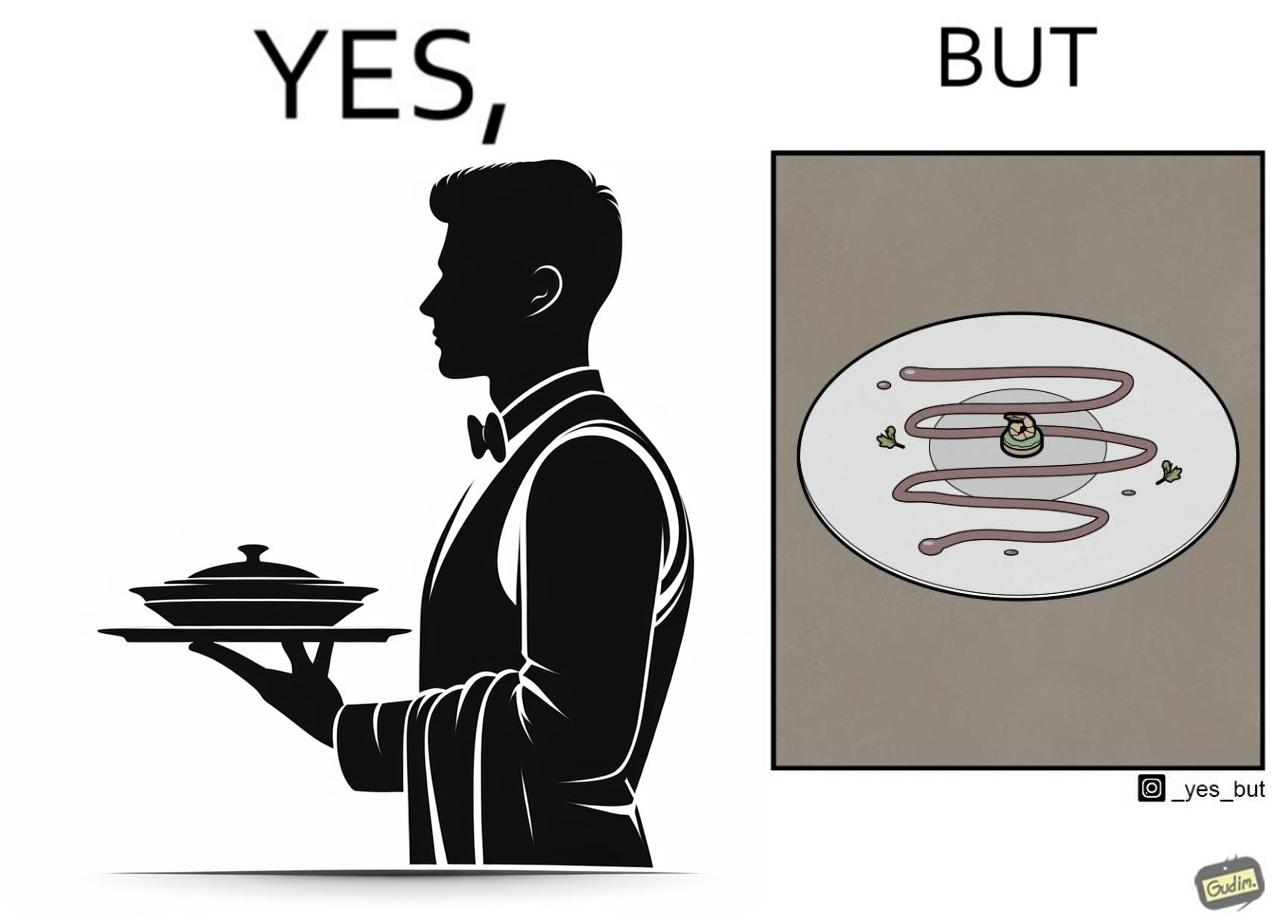Provide a description of this image. The image is ironic, because  in the first image the waiter is bringing the dish to the table presenting it as some lavish dish but in the second image when the dish is shown in the plate its just a small piece to eat 